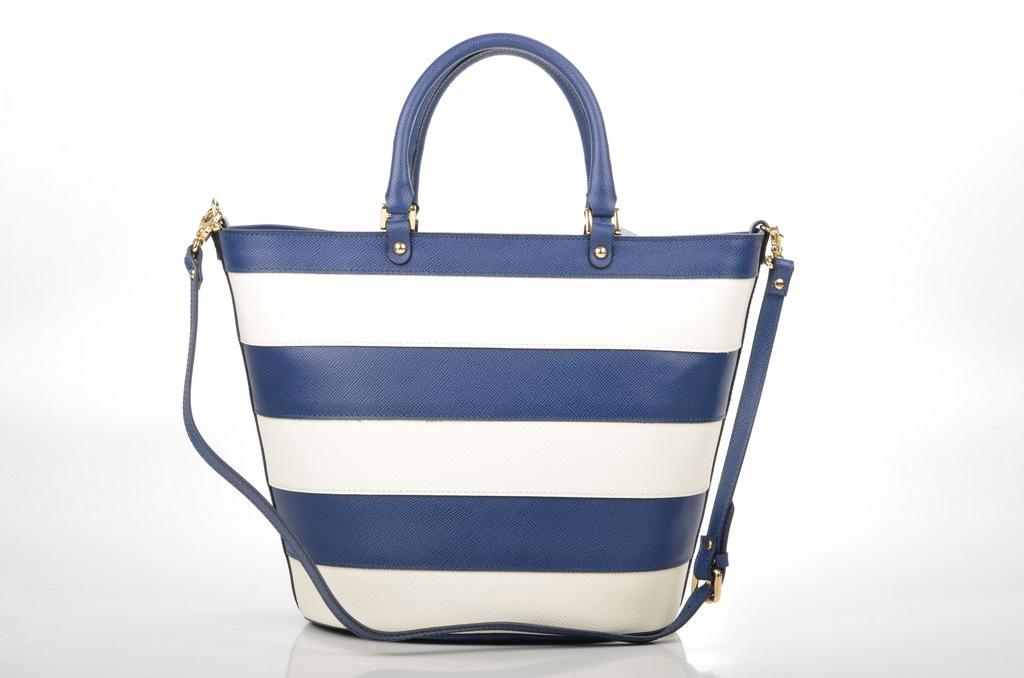What object is in the center of the image? There is a handbag in the center of the image. What colors can be seen on the handbag? The handbag is in white and blue color. What type of meat is being prepared in the image? There is no meat present in the image; it features a handbag in the center. Is there a tub visible in the image? There is no tub present in the image; it only shows a handbag. 